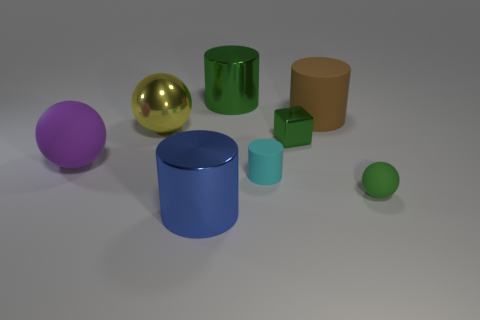Do the cylinder that is behind the brown thing and the tiny cyan thing have the same size?
Your response must be concise. No. Are there fewer matte spheres that are left of the tiny cylinder than green metallic things right of the tiny green matte object?
Keep it short and to the point. No. Does the big metallic ball have the same color as the small matte ball?
Your response must be concise. No. Is the number of large metallic balls in front of the green ball less than the number of small green rubber balls?
Provide a succinct answer. Yes. There is a small cube that is the same color as the tiny rubber ball; what is it made of?
Your answer should be very brief. Metal. Is the material of the cyan cylinder the same as the brown cylinder?
Keep it short and to the point. Yes. What number of tiny cyan cylinders are made of the same material as the brown thing?
Your answer should be very brief. 1. There is a cylinder that is the same material as the blue thing; what color is it?
Offer a terse response. Green. The cyan thing has what shape?
Keep it short and to the point. Cylinder. What is the material of the cylinder that is in front of the small matte ball?
Offer a very short reply. Metal. 